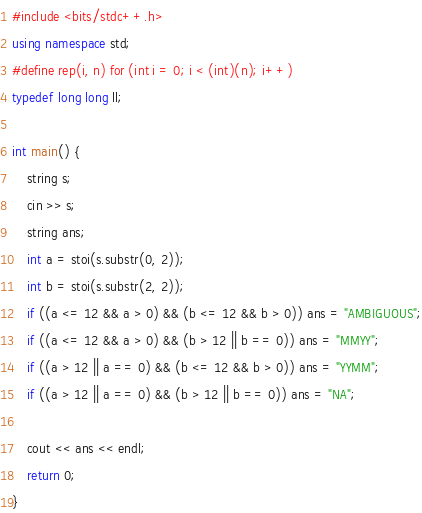<code> <loc_0><loc_0><loc_500><loc_500><_C++_>#include <bits/stdc++.h>
using namespace std;
#define rep(i, n) for (int i = 0; i < (int)(n); i++)
typedef long long ll;

int main() {
    string s;
    cin >> s;
    string ans;
    int a = stoi(s.substr(0, 2));
    int b = stoi(s.substr(2, 2));
    if ((a <= 12 && a > 0) && (b <= 12 && b > 0)) ans = "AMBIGUOUS";
    if ((a <= 12 && a > 0) && (b > 12 || b == 0)) ans = "MMYY";
    if ((a > 12 || a == 0) && (b <= 12 && b > 0)) ans = "YYMM";
    if ((a > 12 || a == 0) && (b > 12 || b == 0)) ans = "NA";

    cout << ans << endl;
    return 0;
}</code> 